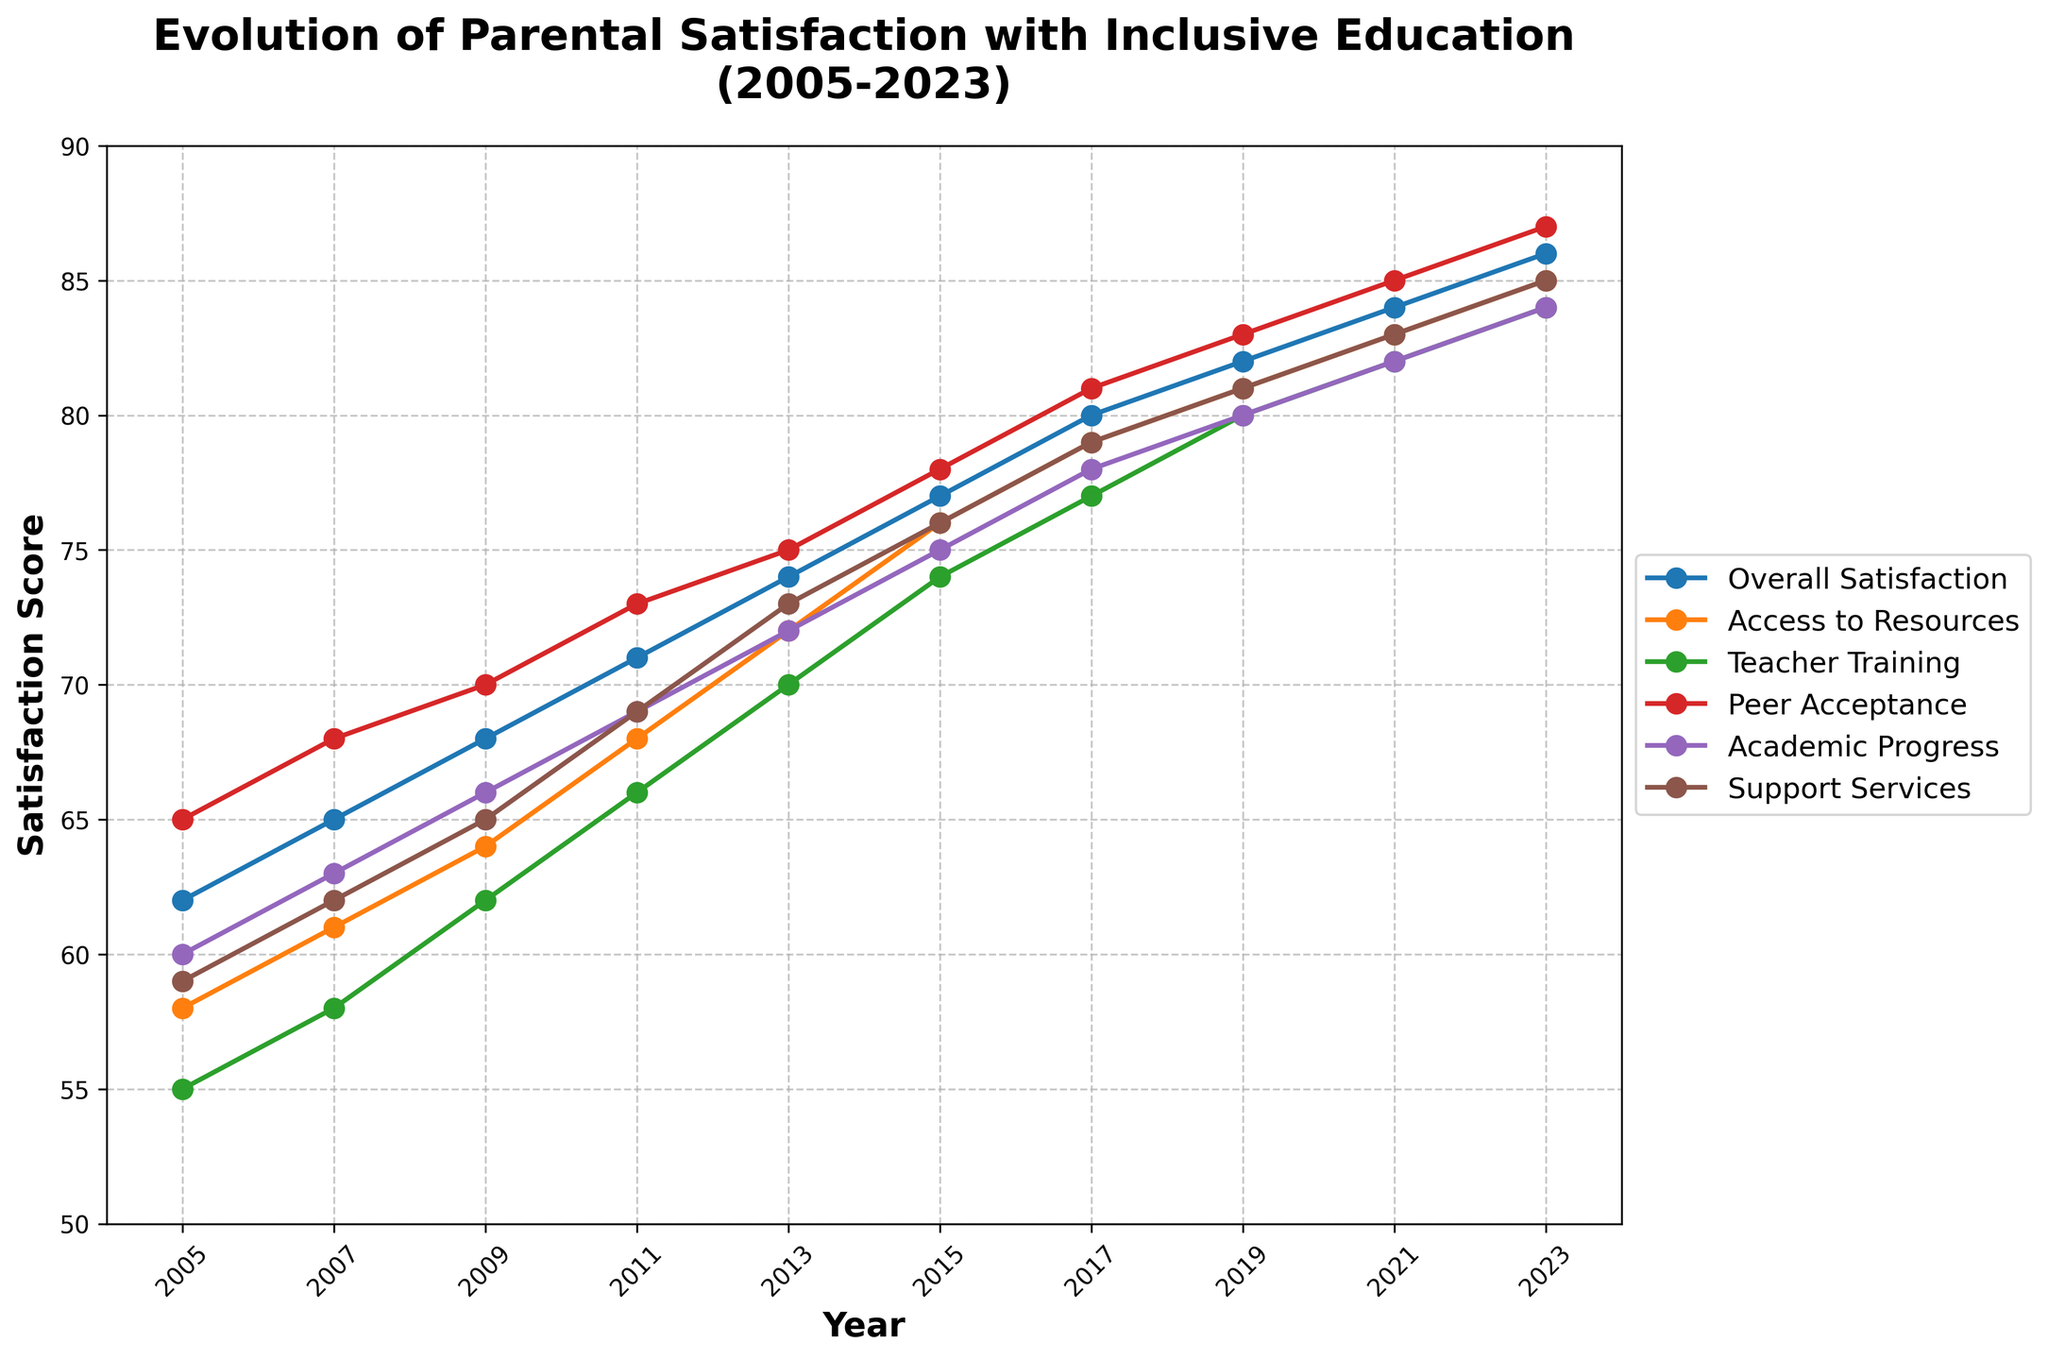What's the overall trend in parental satisfaction scores from 2005 to 2023? The overall trend in parental satisfaction scores shows a consistent increase from 62 in 2005 to 86 in 2023. This can be observed by noting the upward slope of the "Overall Satisfaction" line on the chart.
Answer: Increasing Which category has the highest satisfaction score in 2023? By examining the chart, the "Peer Acceptance" and "Support Services" categories each have the highest score in 2023, both at 87 and 85, respectively.
Answer: Peer Acceptance Between 2007 and 2015, which category had the most significant increase in satisfaction score? To find this, subtract the 2007 scores from the 2015 scores for each category:
- Overall Satisfaction: 77 - 65 = 12
- Access to Resources: 76 - 61 = 15
- Teacher Training: 74 - 58 = 16
- Peer Acceptance: 78 - 68 = 10
- Academic Progress: 75 - 63 = 12
- Support Services: 76 - 62 = 14 
The "Teacher Training" category had the most significant increase of 16 points.
Answer: Teacher Training What is the difference between the "Academic Progress" and "Teacher Training" satisfaction scores in 2011? Subtract the "Teacher Training" score from the "Academic Progress" score for 2011:
69 - 66 = 3
Answer: 3 How does the "Access to Resources" satisfaction score in 2005 compare to the "Support Services" satisfaction score in 2005? Both have relatively close scores in 2005: 
- Access to Resources: 58
- Support Services: 59
The "Support Services" satisfaction score is slightly higher than "Access to Resources" by 1 point.
Answer: Support Services is higher by 1 point Which year saw the highest increase in the "Overall Satisfaction" score compared to the previous year? To find the year with the highest increase:
- From 2005 to 2007: 65 - 62 = 3
- From 2007 to 2009: 68 - 65 = 3
- From 2009 to 2011: 71 - 68 = 3
- From 2011 to 2013: 74 - 71 = 3
- From 2013 to 2015: 77 - 74 = 3
- From 2015 to 2017: 80 - 77 = 3
- From 2017 to 2019: 82 - 80 = 2
- From 2019 to 2021: 84 - 82 = 2
- From 2021 to 2023: 86 - 84 = 2
No particular year saw a dramatic increase, the increments were steady at either 3 or 2 points.
Answer: Regular increments On average, what is the satisfaction score across all categories in 2023? Calculate the average by summing the satisfaction scores in each category and dividing by the number of categories:
- (86 + 85 + 84 + 87 + 84 + 85) / 6 = 511 / 6 ≈ 85.2
Answer: 85.2 Which two categories had the closest satisfaction scores in 2019? Analyzing the 2019 scores:
- Overall Satisfaction: 82
- Access to Resources: 81
- Teacher Training: 80
- Peer Acceptance: 83
- Academic Progress: 80
- Support Services: 81 
"Access to Resources" and "Support Services" both had scores of 81, which are closest.
Answer: Access to Resources and Support Services How much did the "Peer Acceptance" satisfaction score change from 2005 to 2023? Subtract the score from 2005 from the score in 2023 for "Peer Acceptance":
87 - 65 = 22
Answer: 22 Which category showed the least change in satisfaction score from 2005 to 2023? Calculate the difference for each category:
- Overall Satisfaction: 86 - 62 = 24
- Access to Resources: 85 - 58 = 27
- Teacher Training: 84 - 55 = 29
- Peer Acceptance: 87 - 65 = 22
- Academic Progress: 84 - 60 = 24
- Support Services: 85 - 59 = 26 
The "Peer Acceptance" category had the smallest change, increasing by 22 points.
Answer: Peer Acceptance 